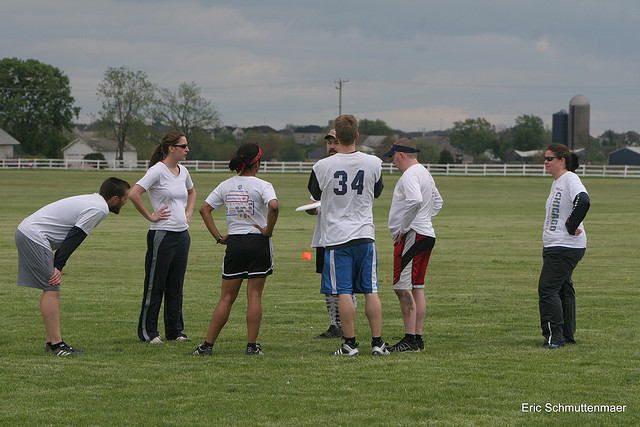<image>What is the number of the player holding the frisbee? I am not sure the number of the player holding the frisbee. But it can be seen 34. What is the animal that is the mascot for the home team in this photo? It is unknown what the mascot for the home team in the photo is. It could be a bear, tiger, or bird. What is the number of the player holding the frisbee? I don't know which number is the player holding the frisbee. It can be seen as '34' or 'thirty 4'. What is the animal that is the mascot for the home team in this photo? It is unknown what is the animal that is the mascot for the home team in this photo. It can be seen 'bear', 'tiger' or 'chicago wildfire'. 